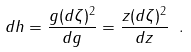Convert formula to latex. <formula><loc_0><loc_0><loc_500><loc_500>d h = \frac { g ( d \zeta ) ^ { 2 } } { d g } = \frac { z ( d \zeta ) ^ { 2 } } { d z } \ .</formula> 